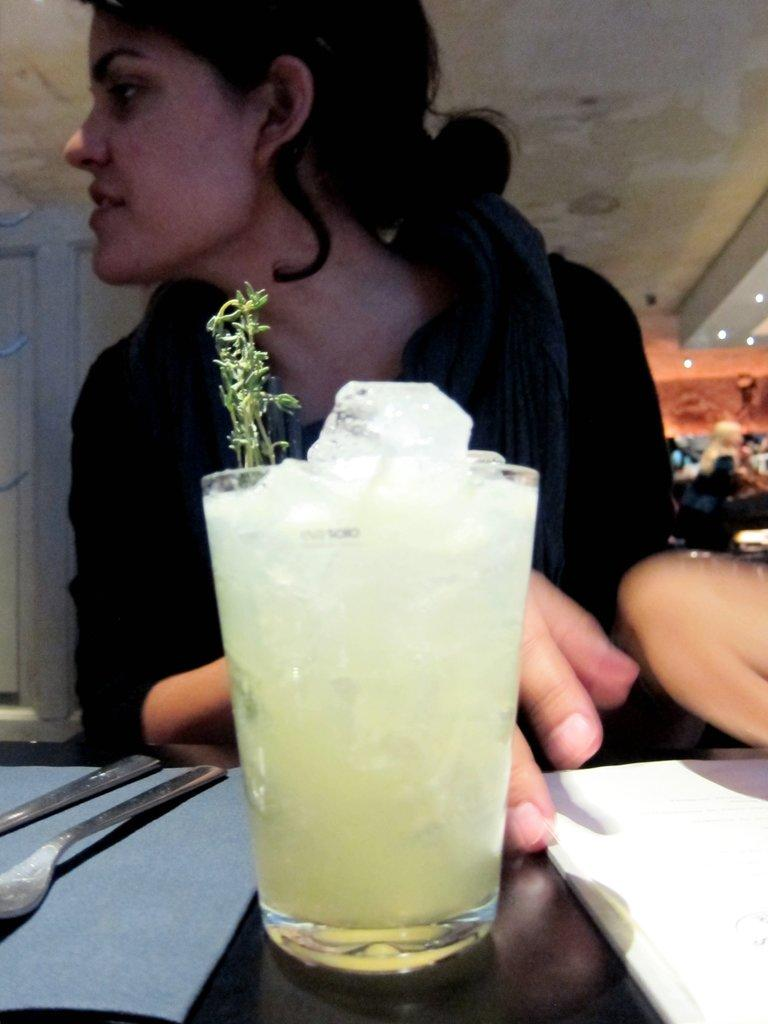What is the woman doing in the image? The woman is sitting in front of the table. What objects can be seen on the table? There are spoons, a glass with ice, and a book on the table. What type of beast is present in the image? There is no beast present in the image. How many steps are visible in the image? The image does not show any steps; it only features a woman sitting in front of a table with various objects on it. 